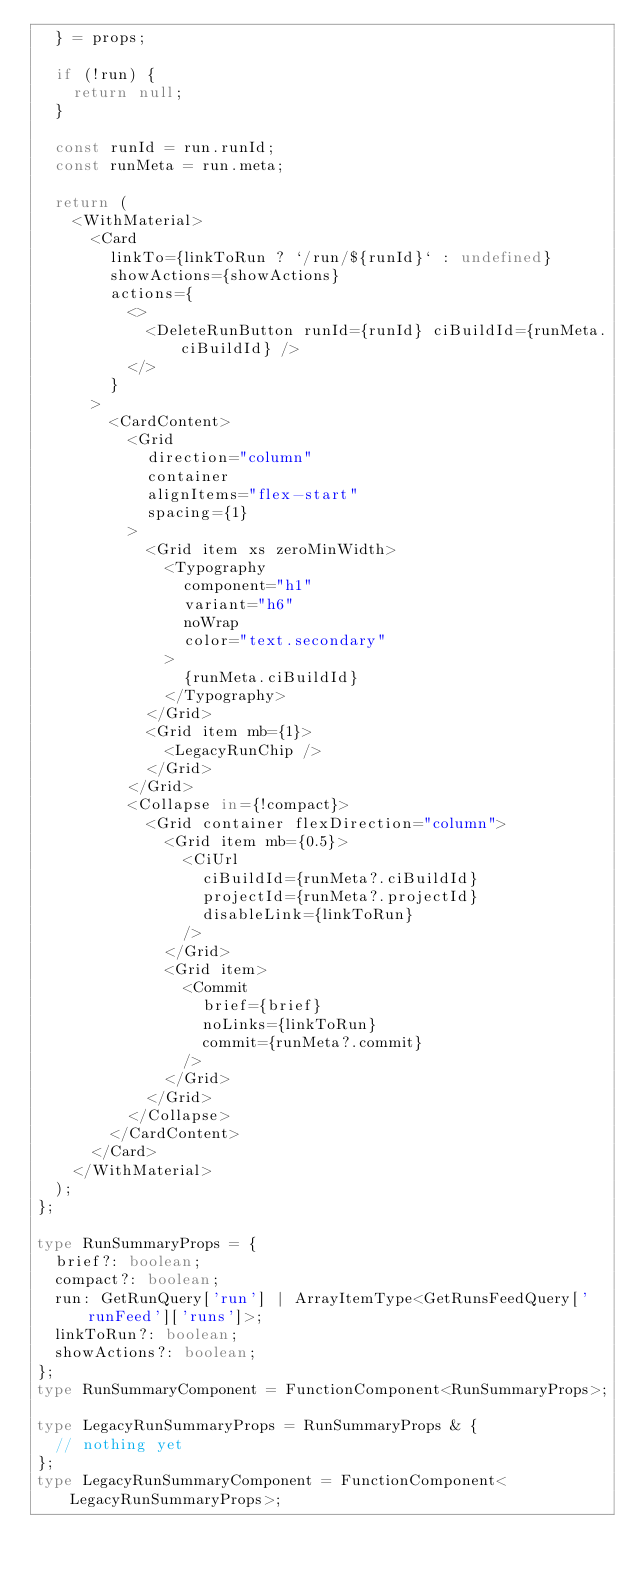<code> <loc_0><loc_0><loc_500><loc_500><_TypeScript_>  } = props;

  if (!run) {
    return null;
  }

  const runId = run.runId;
  const runMeta = run.meta;

  return (
    <WithMaterial>
      <Card
        linkTo={linkToRun ? `/run/${runId}` : undefined}
        showActions={showActions}
        actions={
          <>
            <DeleteRunButton runId={runId} ciBuildId={runMeta.ciBuildId} />
          </>
        }
      >
        <CardContent>
          <Grid
            direction="column"
            container
            alignItems="flex-start"
            spacing={1}
          >
            <Grid item xs zeroMinWidth>
              <Typography
                component="h1"
                variant="h6"
                noWrap
                color="text.secondary"
              >
                {runMeta.ciBuildId}
              </Typography>
            </Grid>
            <Grid item mb={1}>
              <LegacyRunChip />
            </Grid>
          </Grid>
          <Collapse in={!compact}>
            <Grid container flexDirection="column">
              <Grid item mb={0.5}>
                <CiUrl
                  ciBuildId={runMeta?.ciBuildId}
                  projectId={runMeta?.projectId}
                  disableLink={linkToRun}
                />
              </Grid>
              <Grid item>
                <Commit
                  brief={brief}
                  noLinks={linkToRun}
                  commit={runMeta?.commit}
                />
              </Grid>
            </Grid>
          </Collapse>
        </CardContent>
      </Card>
    </WithMaterial>
  );
};

type RunSummaryProps = {
  brief?: boolean;
  compact?: boolean;
  run: GetRunQuery['run'] | ArrayItemType<GetRunsFeedQuery['runFeed']['runs']>;
  linkToRun?: boolean;
  showActions?: boolean;
};
type RunSummaryComponent = FunctionComponent<RunSummaryProps>;

type LegacyRunSummaryProps = RunSummaryProps & {
  // nothing yet
};
type LegacyRunSummaryComponent = FunctionComponent<LegacyRunSummaryProps>;
</code> 